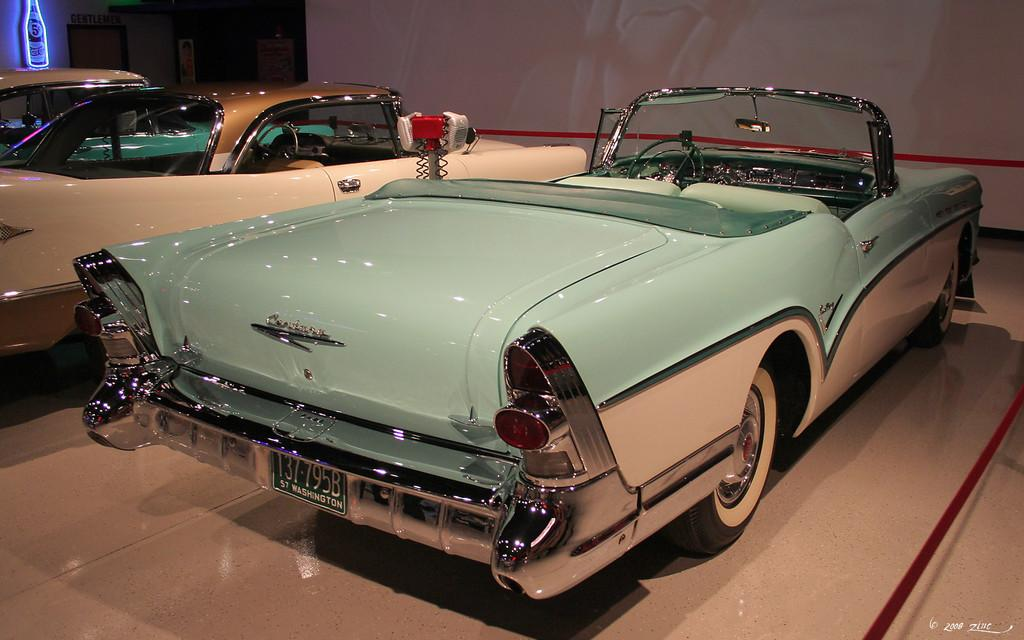What objects are on the floor in the image? There are vehicles on the floor in the image. What type of decorations are present in the image? There are posters in the image. What is the container visible in the image? There is a bottle in the image. What feature allows access to another area in the image? There is a door in the image. What can be seen in the background of the image? There is a wall visible in the background of the image. What type of vase is placed on the edge of the door in the image? There is no vase present in the image, and the door does not have an edge. 